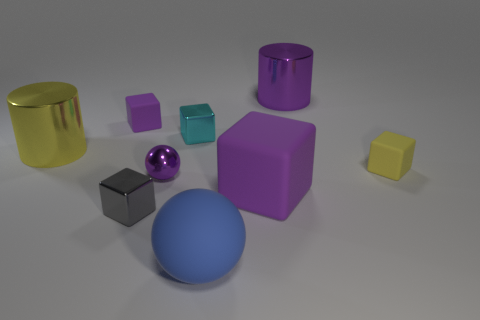Subtract all large purple cubes. How many cubes are left? 4 Subtract all purple cubes. How many cubes are left? 3 Subtract 1 balls. How many balls are left? 1 Subtract all cyan cubes. Subtract all green cylinders. How many cubes are left? 4 Subtract all yellow blocks. How many purple spheres are left? 1 Subtract all purple rubber cubes. Subtract all purple objects. How many objects are left? 3 Add 8 big blue matte things. How many big blue matte things are left? 9 Add 3 yellow metallic things. How many yellow metallic things exist? 4 Add 1 yellow matte things. How many objects exist? 10 Subtract 1 cyan cubes. How many objects are left? 8 